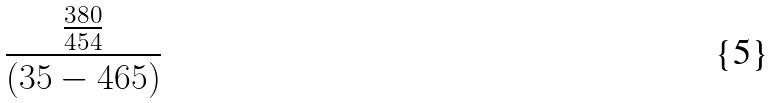<formula> <loc_0><loc_0><loc_500><loc_500>\frac { \frac { 3 8 0 } { 4 5 4 } } { ( 3 5 - 4 6 5 ) }</formula> 